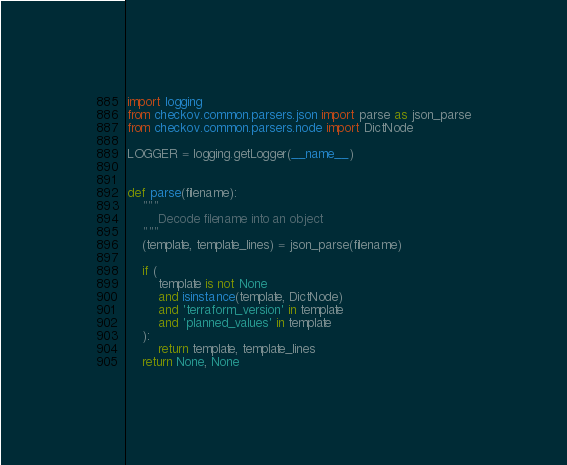Convert code to text. <code><loc_0><loc_0><loc_500><loc_500><_Python_>import logging
from checkov.common.parsers.json import parse as json_parse
from checkov.common.parsers.node import DictNode

LOGGER = logging.getLogger(__name__)


def parse(filename):
    """
        Decode filename into an object
    """
    (template, template_lines) = json_parse(filename)

    if (
        template is not None
        and isinstance(template, DictNode)
        and 'terraform_version' in template
        and 'planned_values' in template
    ):
        return template, template_lines
    return None, None
</code> 